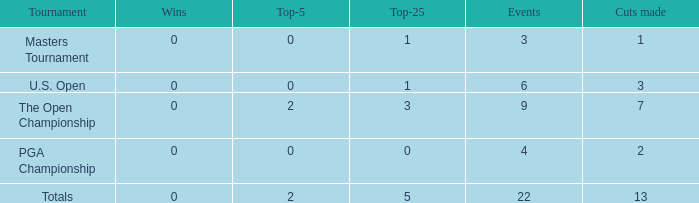What is the cumulative sum of triumphs for instances with below 2 top-5s, under 5 top-25s, and in excess of 4 events engaged in? 1.0. 